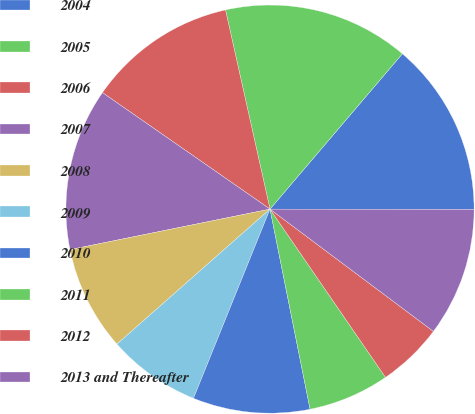Convert chart. <chart><loc_0><loc_0><loc_500><loc_500><pie_chart><fcel>2004<fcel>2005<fcel>2006<fcel>2007<fcel>2008<fcel>2009<fcel>2010<fcel>2011<fcel>2012<fcel>2013 and Thereafter<nl><fcel>13.79%<fcel>14.73%<fcel>11.83%<fcel>12.85%<fcel>8.32%<fcel>7.38%<fcel>9.26%<fcel>6.43%<fcel>5.2%<fcel>10.2%<nl></chart> 